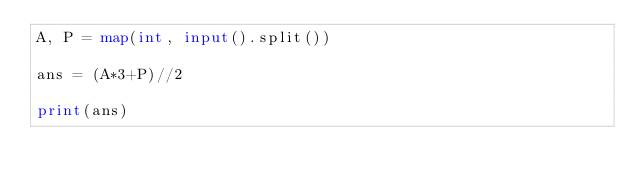Convert code to text. <code><loc_0><loc_0><loc_500><loc_500><_Python_>A, P = map(int, input().split())

ans = (A*3+P)//2

print(ans)</code> 